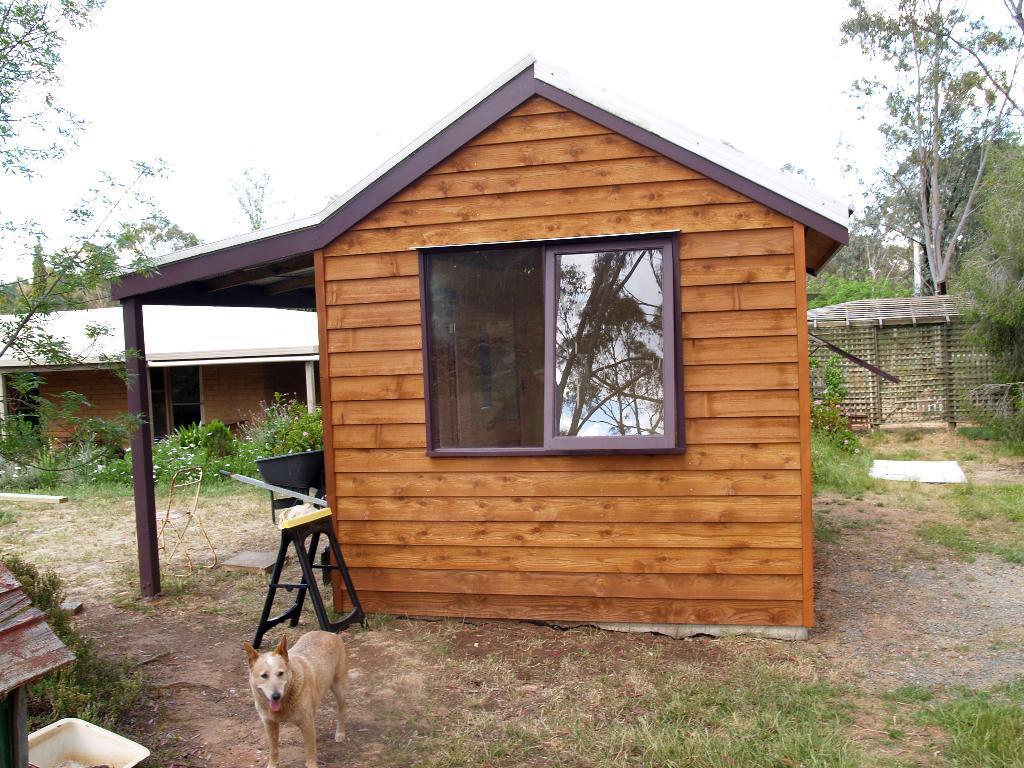Please provide a concise description of this image. In this image there is a building. On the ground there is a dog, table, basket. In the background there is a building, shelter, trees are there. The sky is clear. 